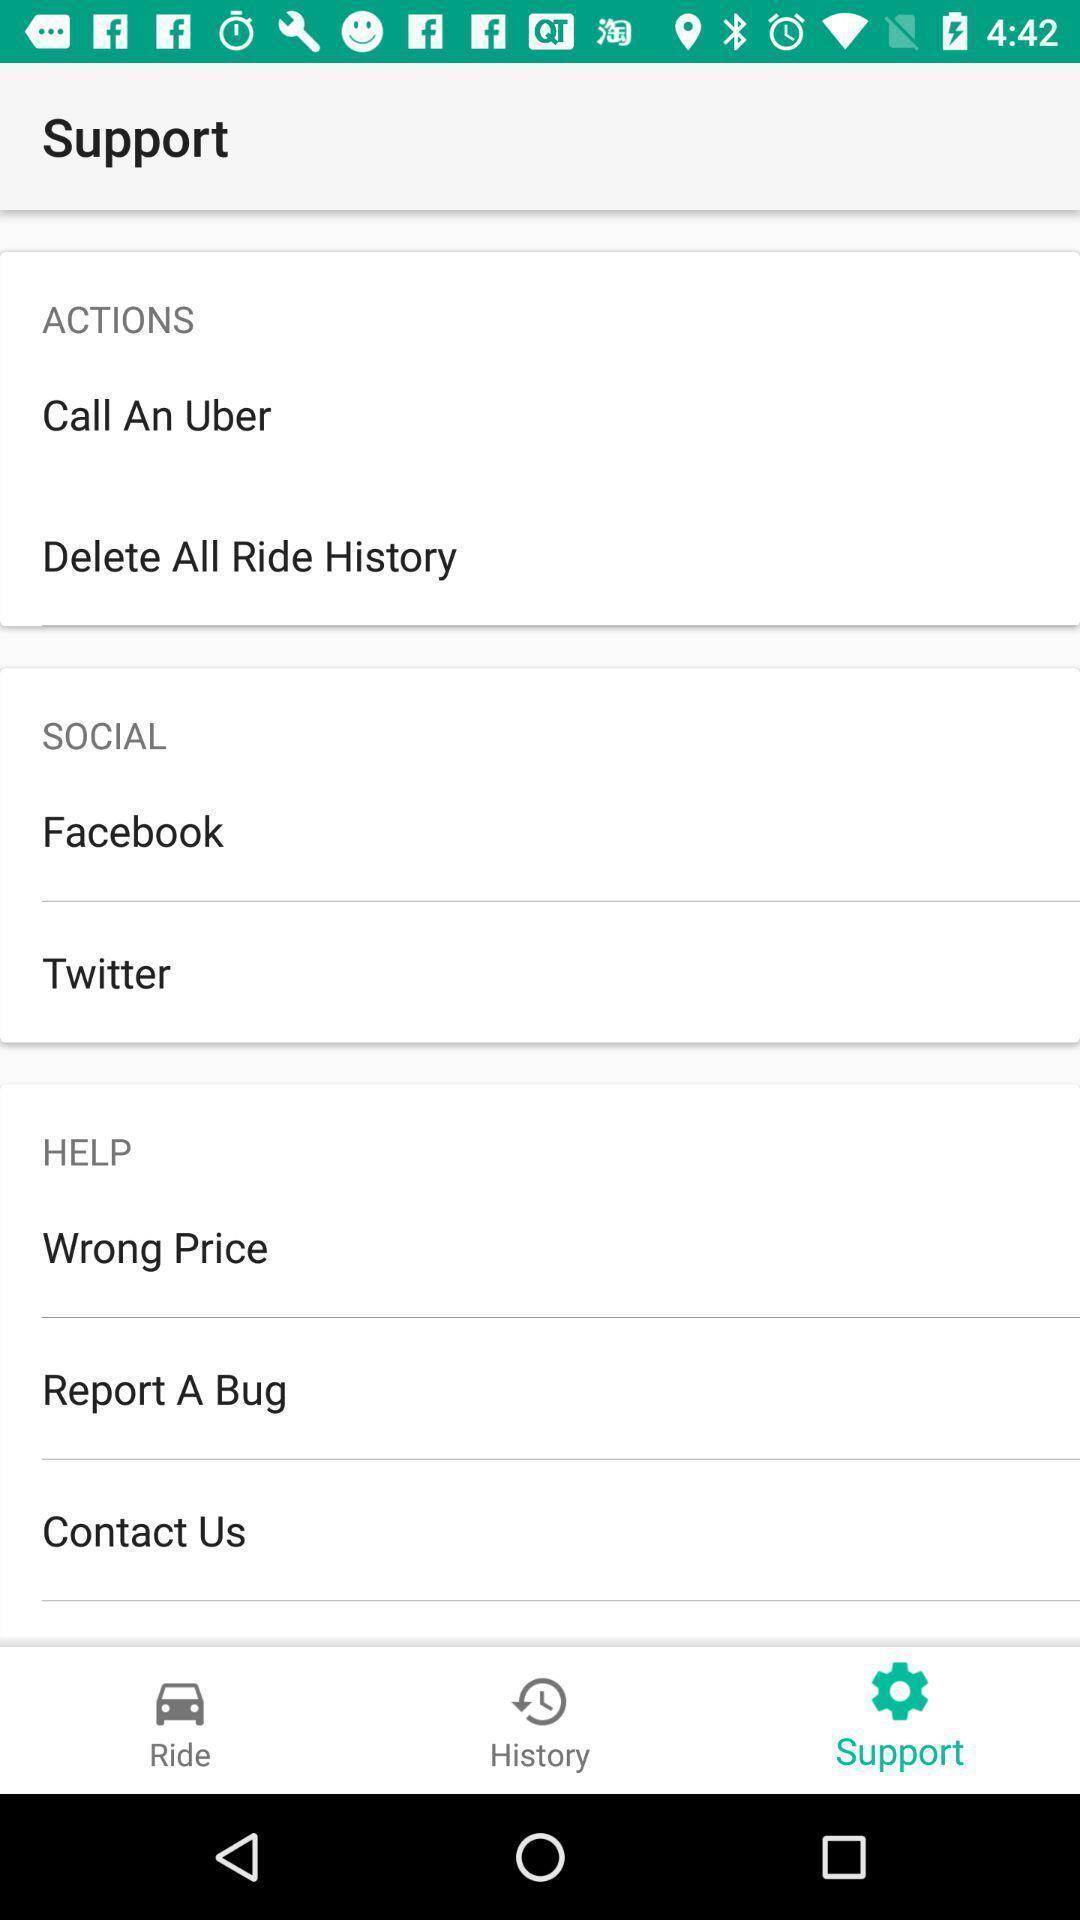Explain the elements present in this screenshot. Support of options in app. 